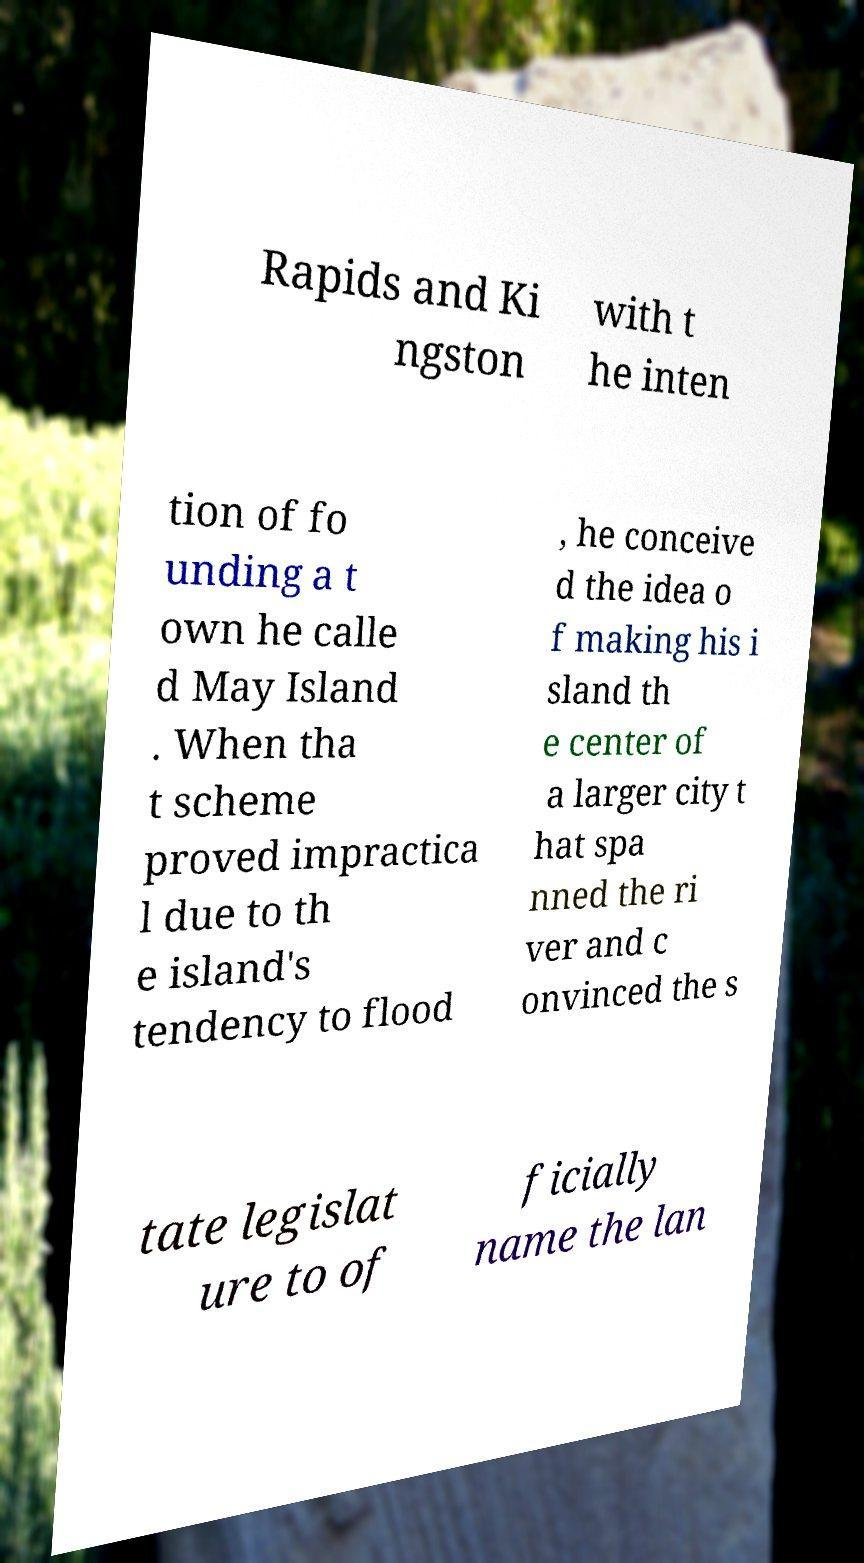Can you accurately transcribe the text from the provided image for me? Rapids and Ki ngston with t he inten tion of fo unding a t own he calle d May Island . When tha t scheme proved impractica l due to th e island's tendency to flood , he conceive d the idea o f making his i sland th e center of a larger city t hat spa nned the ri ver and c onvinced the s tate legislat ure to of ficially name the lan 